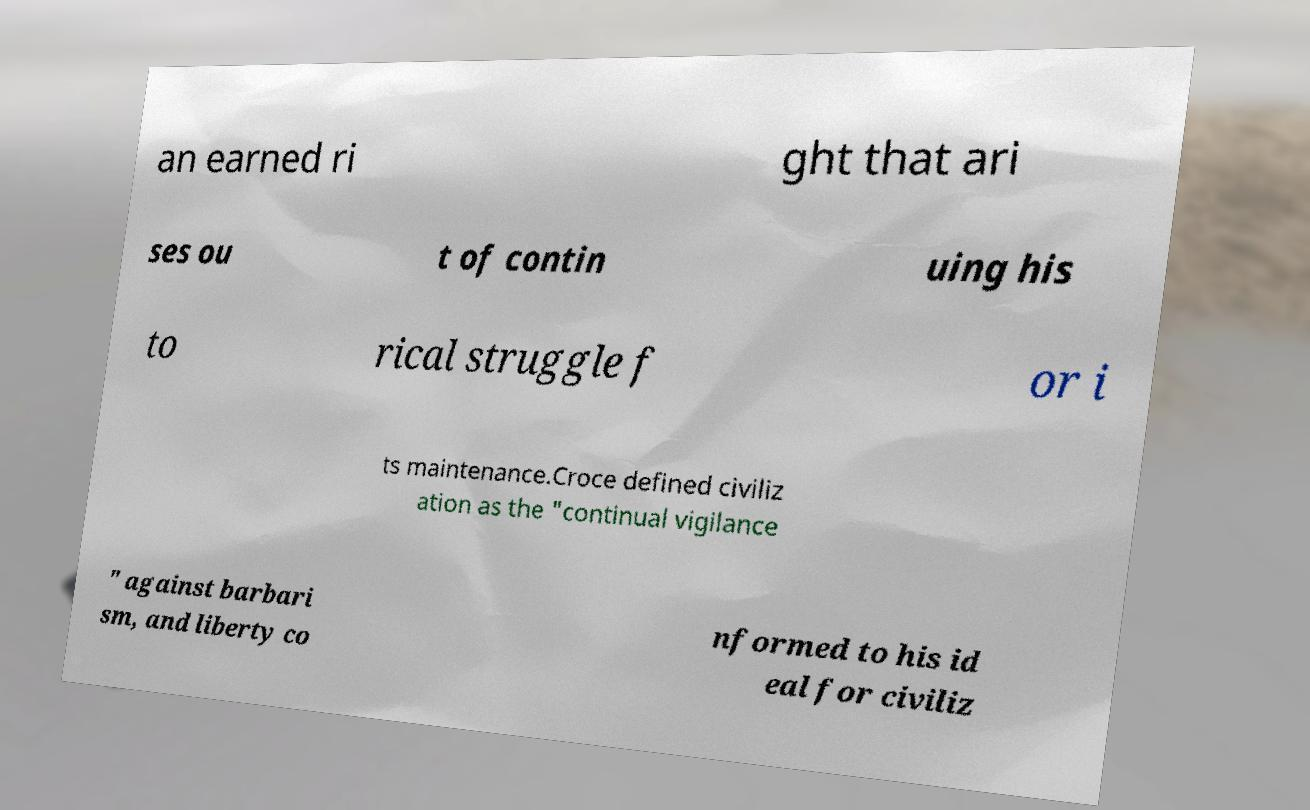Could you extract and type out the text from this image? an earned ri ght that ari ses ou t of contin uing his to rical struggle f or i ts maintenance.Croce defined civiliz ation as the "continual vigilance " against barbari sm, and liberty co nformed to his id eal for civiliz 